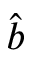Convert formula to latex. <formula><loc_0><loc_0><loc_500><loc_500>\hat { b }</formula> 